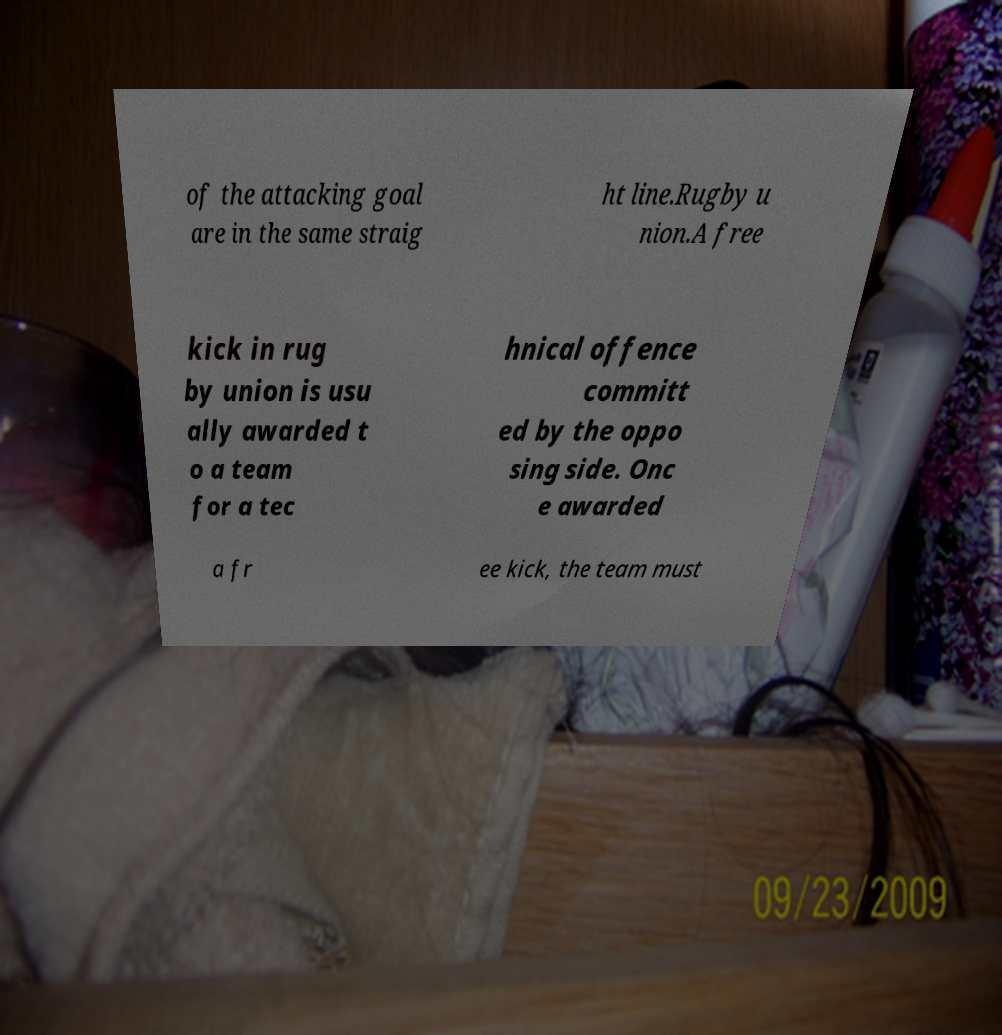Please identify and transcribe the text found in this image. of the attacking goal are in the same straig ht line.Rugby u nion.A free kick in rug by union is usu ally awarded t o a team for a tec hnical offence committ ed by the oppo sing side. Onc e awarded a fr ee kick, the team must 